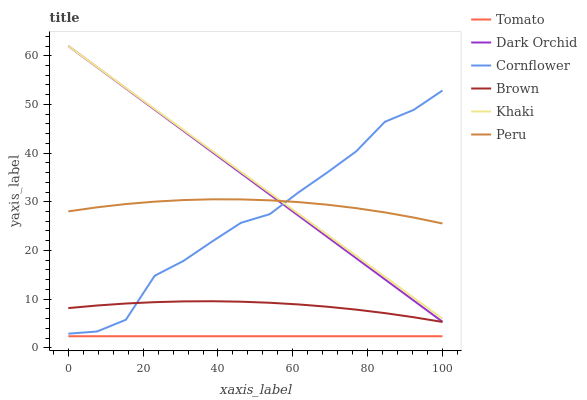Does Tomato have the minimum area under the curve?
Answer yes or no. Yes. Does Khaki have the maximum area under the curve?
Answer yes or no. Yes. Does Cornflower have the minimum area under the curve?
Answer yes or no. No. Does Cornflower have the maximum area under the curve?
Answer yes or no. No. Is Dark Orchid the smoothest?
Answer yes or no. Yes. Is Cornflower the roughest?
Answer yes or no. Yes. Is Khaki the smoothest?
Answer yes or no. No. Is Khaki the roughest?
Answer yes or no. No. Does Tomato have the lowest value?
Answer yes or no. Yes. Does Cornflower have the lowest value?
Answer yes or no. No. Does Dark Orchid have the highest value?
Answer yes or no. Yes. Does Cornflower have the highest value?
Answer yes or no. No. Is Tomato less than Dark Orchid?
Answer yes or no. Yes. Is Peru greater than Brown?
Answer yes or no. Yes. Does Brown intersect Cornflower?
Answer yes or no. Yes. Is Brown less than Cornflower?
Answer yes or no. No. Is Brown greater than Cornflower?
Answer yes or no. No. Does Tomato intersect Dark Orchid?
Answer yes or no. No. 